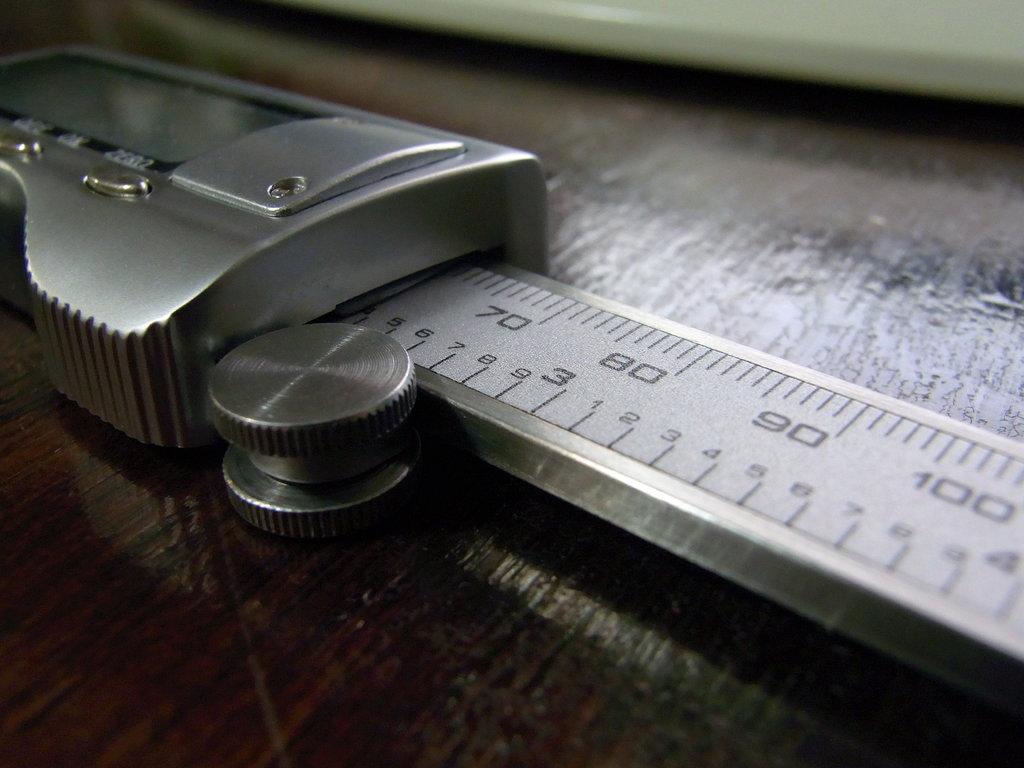What is the largest measurement number seen?
Keep it short and to the point. 100. What is the smallest measurement number seen?
Ensure brevity in your answer.  70. 